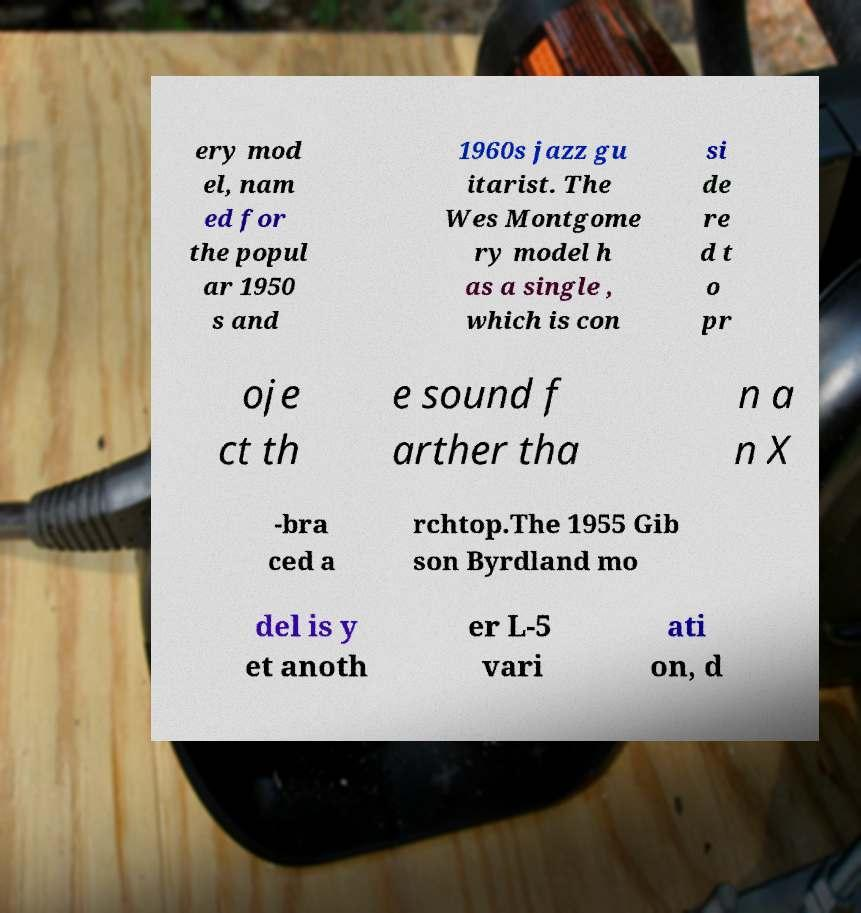What messages or text are displayed in this image? I need them in a readable, typed format. ery mod el, nam ed for the popul ar 1950 s and 1960s jazz gu itarist. The Wes Montgome ry model h as a single , which is con si de re d t o pr oje ct th e sound f arther tha n a n X -bra ced a rchtop.The 1955 Gib son Byrdland mo del is y et anoth er L-5 vari ati on, d 